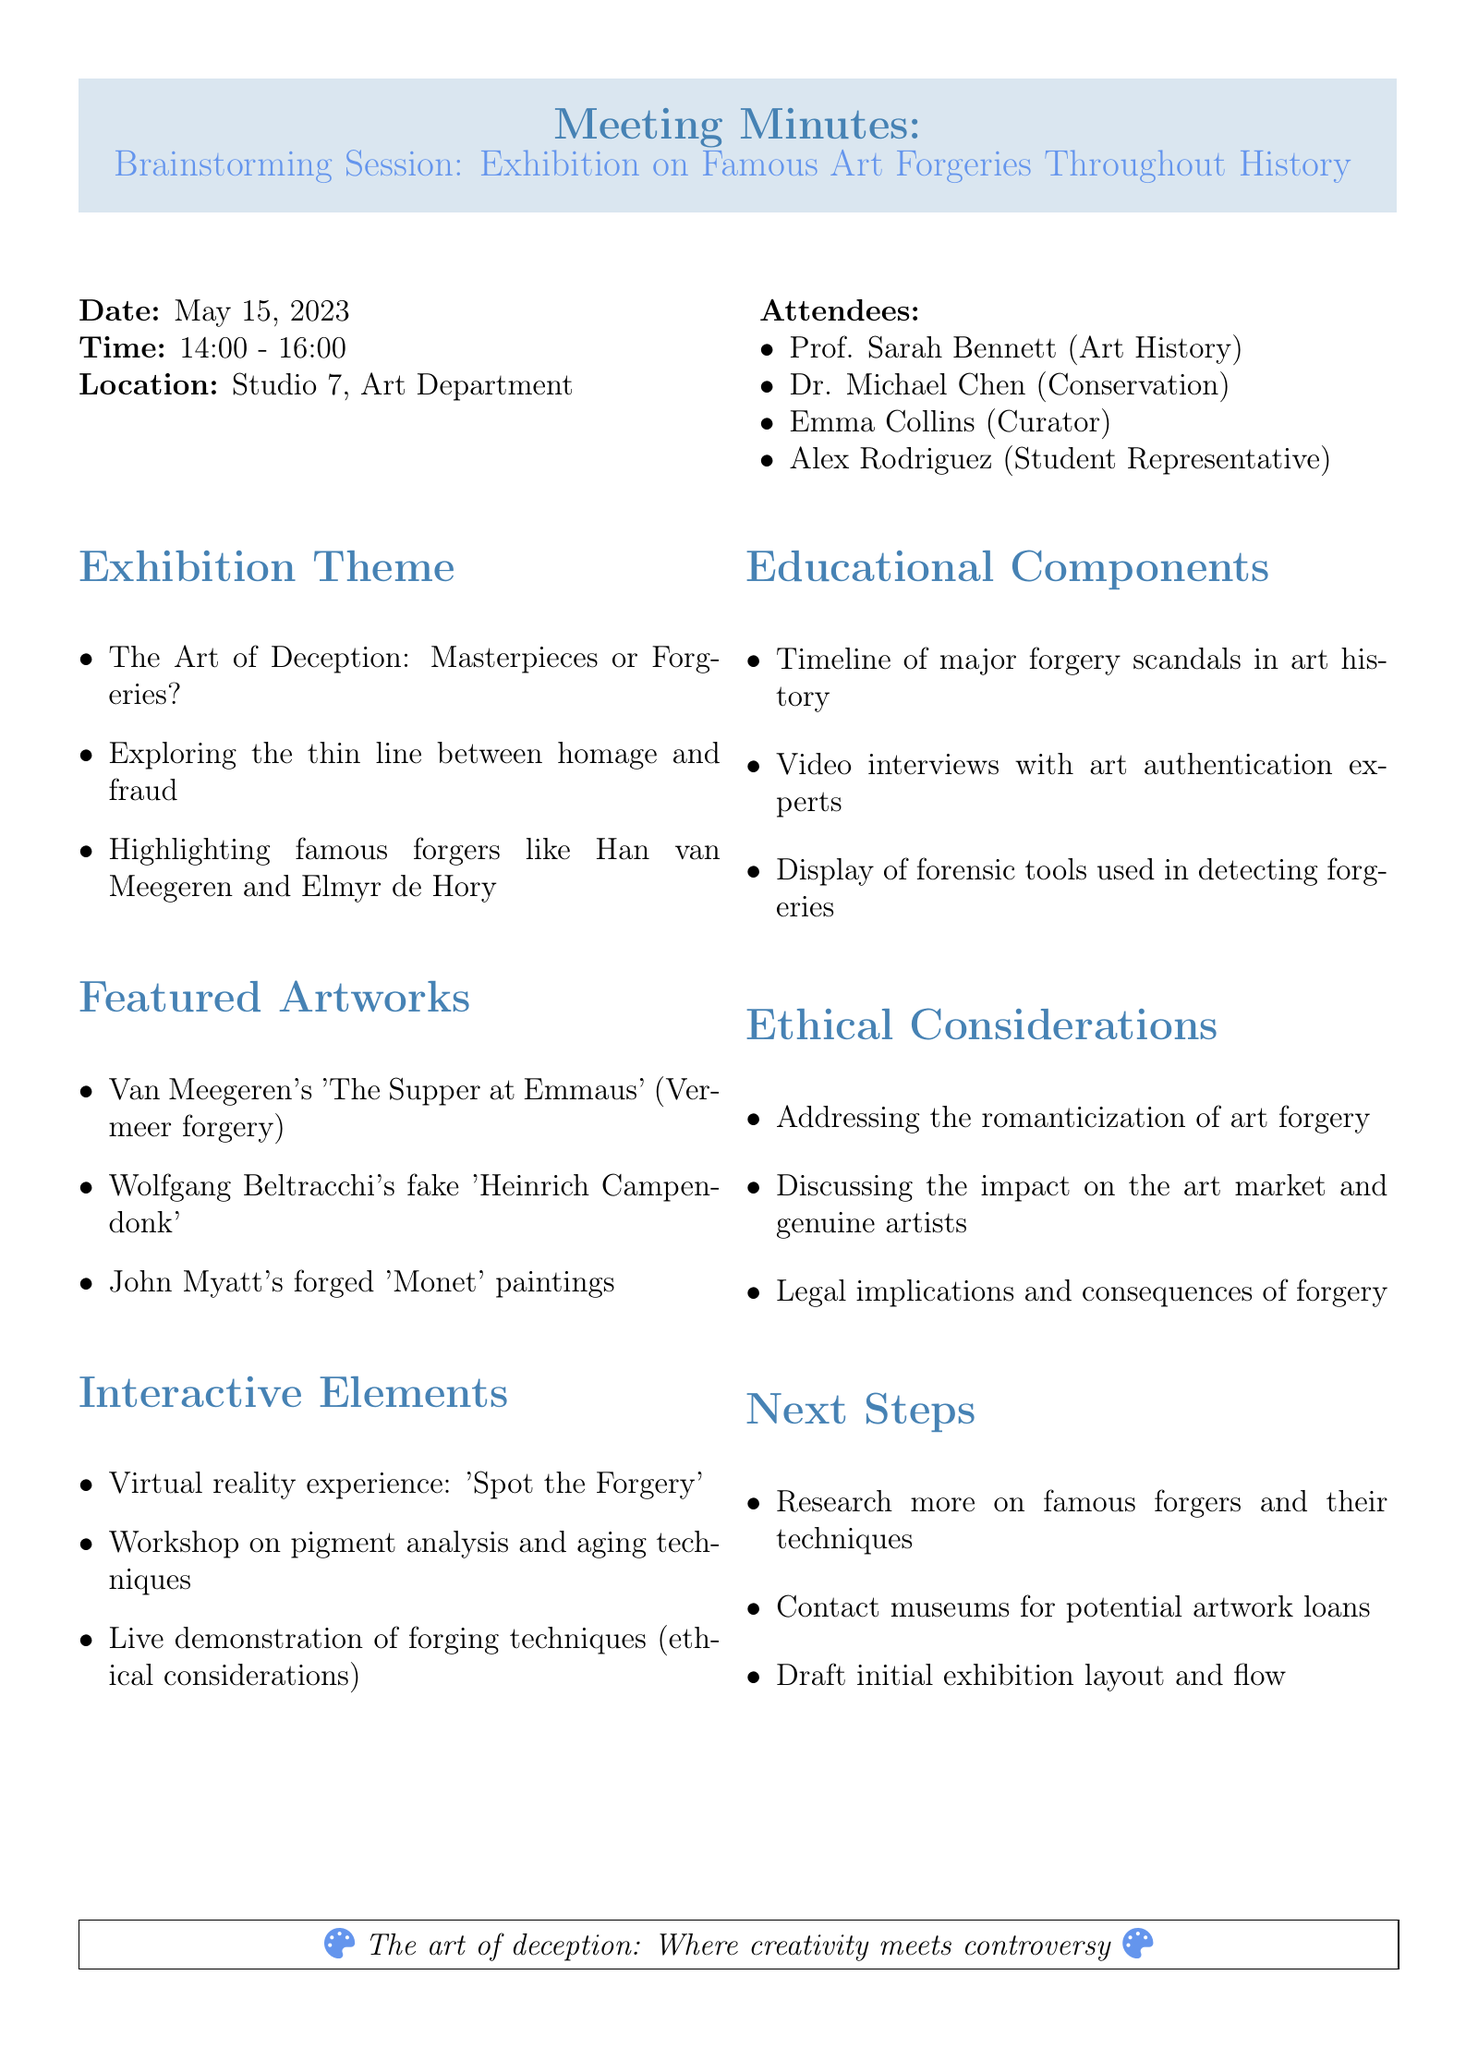what is the date of the meeting? The date of the meeting is explicitly stated in the document under "Date."
Answer: May 15, 2023 who is the Student Representative? The name of the Student Representative is listed among the attendees.
Answer: Alex Rodriguez what is one of the highlighted forgers? The discussion mentions notable forgers that are to be highlighted in the exhibition.
Answer: Han van Meegeren what is one interactive element proposed for the exhibition? The document lists various interactive elements discussed during the meeting.
Answer: Virtual reality experience: 'Spot the Forgery' what are the ethical considerations related to the exhibition? This section provides insights on the topics that need to be addressed from an ethical standpoint.
Answer: Romanticization of art forgery how long did the meeting last? The time of the meeting is given, from start to finish, which allows calculation of duration.
Answer: 2 hours how many main agenda topics were discussed? The "agenda_items" section outlines the different topics that were covered in the meeting.
Answer: 6 what is a proposed next step for the exhibition? This is found in the "Next Steps" section, detailing actions to take after the meeting.
Answer: Research more on famous forgers and their techniques who is the Curator present at the meeting? The attendees' list names the Curator among other participants.
Answer: Emma Collins 